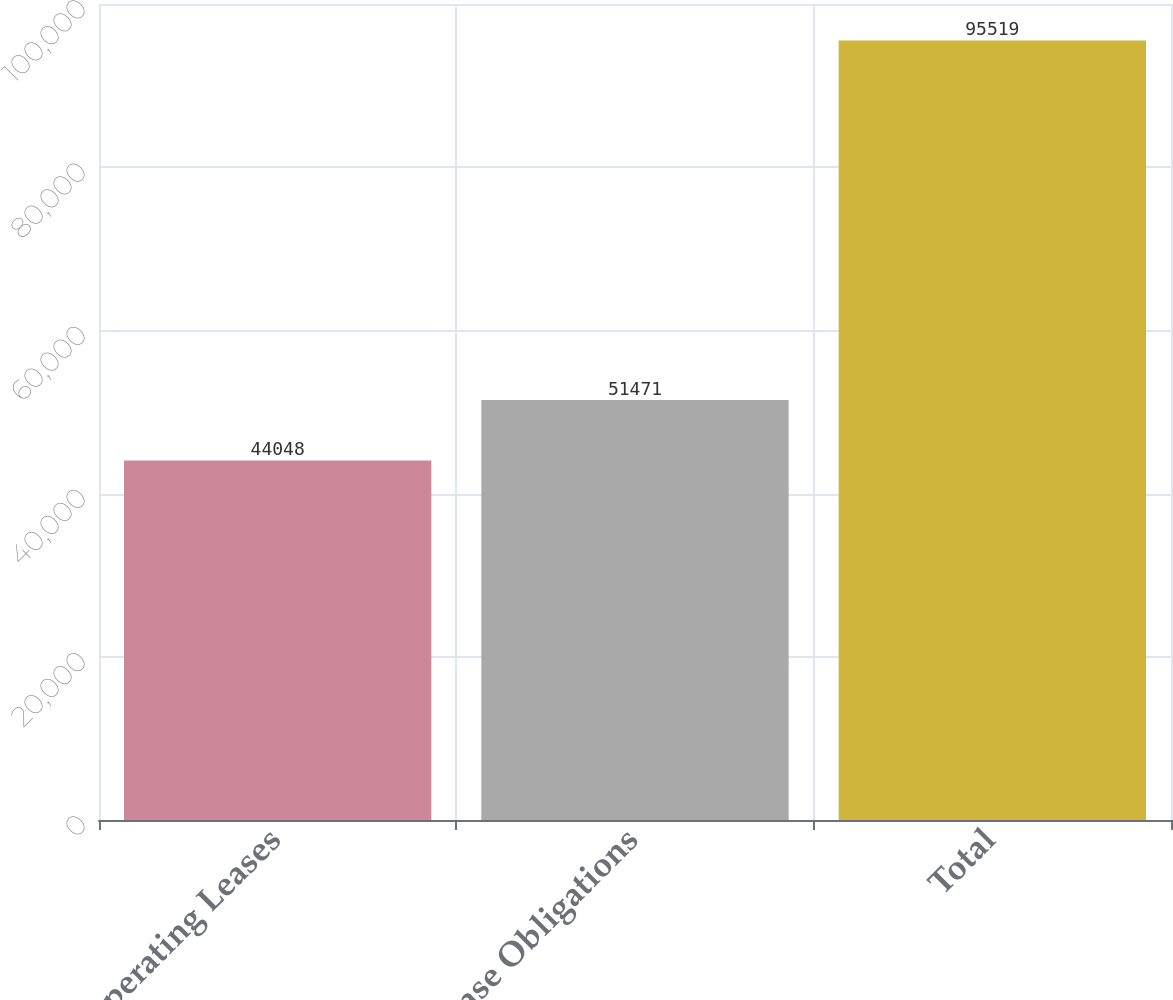Convert chart. <chart><loc_0><loc_0><loc_500><loc_500><bar_chart><fcel>Operating Leases<fcel>Purchase Obligations<fcel>Total<nl><fcel>44048<fcel>51471<fcel>95519<nl></chart> 